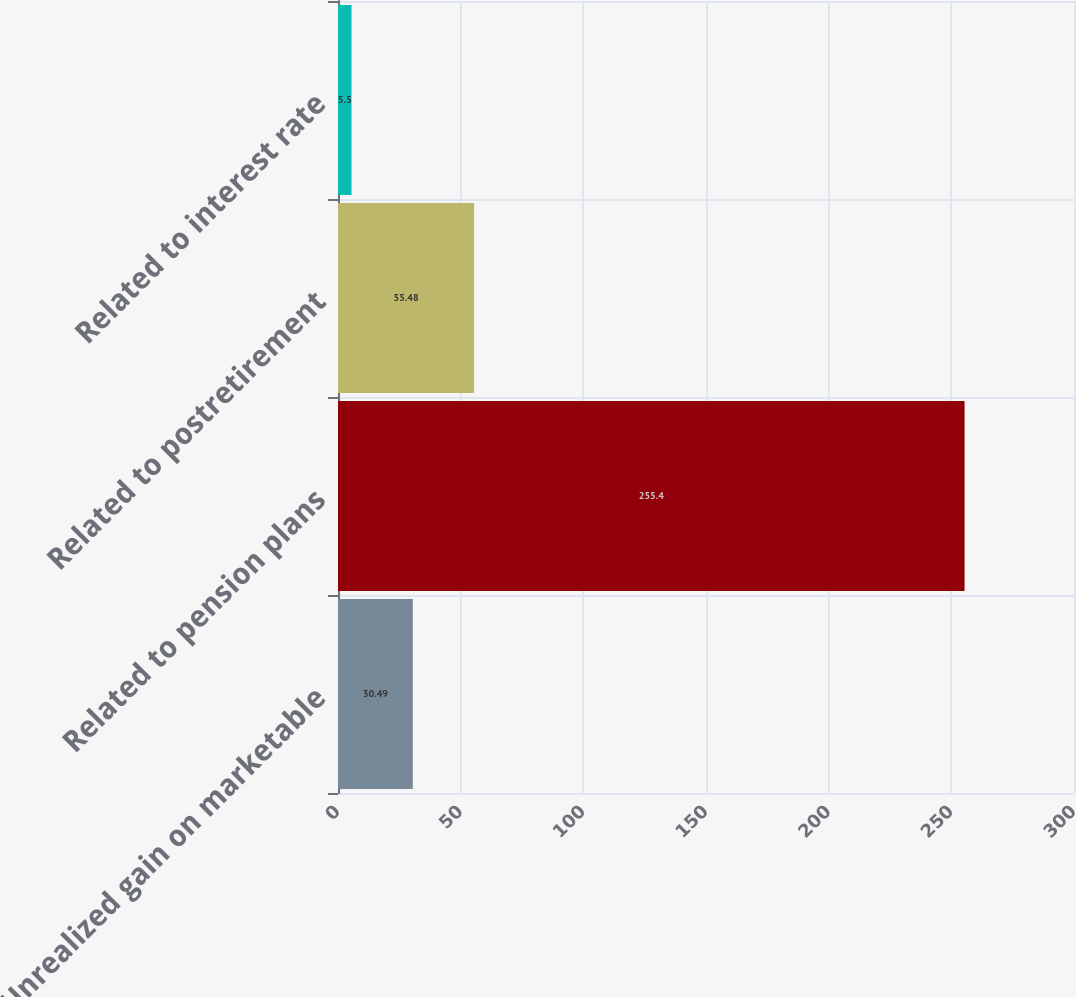<chart> <loc_0><loc_0><loc_500><loc_500><bar_chart><fcel>Unrealized gain on marketable<fcel>Related to pension plans<fcel>Related to postretirement<fcel>Related to interest rate<nl><fcel>30.49<fcel>255.4<fcel>55.48<fcel>5.5<nl></chart> 